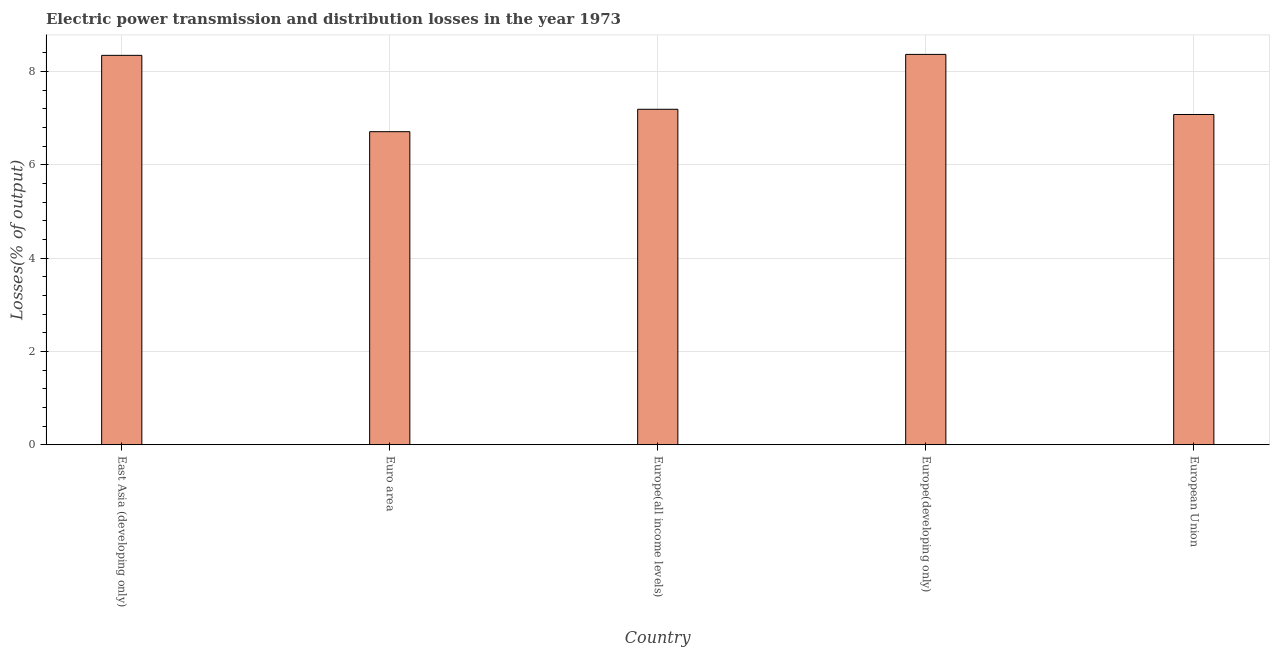What is the title of the graph?
Your response must be concise. Electric power transmission and distribution losses in the year 1973. What is the label or title of the Y-axis?
Provide a short and direct response. Losses(% of output). What is the electric power transmission and distribution losses in East Asia (developing only)?
Your answer should be very brief. 8.35. Across all countries, what is the maximum electric power transmission and distribution losses?
Provide a succinct answer. 8.37. Across all countries, what is the minimum electric power transmission and distribution losses?
Offer a terse response. 6.71. In which country was the electric power transmission and distribution losses maximum?
Offer a terse response. Europe(developing only). What is the sum of the electric power transmission and distribution losses?
Your answer should be compact. 37.7. What is the difference between the electric power transmission and distribution losses in Euro area and Europe(all income levels)?
Your response must be concise. -0.48. What is the average electric power transmission and distribution losses per country?
Provide a short and direct response. 7.54. What is the median electric power transmission and distribution losses?
Give a very brief answer. 7.19. In how many countries, is the electric power transmission and distribution losses greater than 7.2 %?
Give a very brief answer. 2. What is the difference between the highest and the second highest electric power transmission and distribution losses?
Keep it short and to the point. 0.02. What is the difference between the highest and the lowest electric power transmission and distribution losses?
Ensure brevity in your answer.  1.66. How many bars are there?
Offer a terse response. 5. Are all the bars in the graph horizontal?
Offer a very short reply. No. How many countries are there in the graph?
Provide a succinct answer. 5. What is the Losses(% of output) in East Asia (developing only)?
Ensure brevity in your answer.  8.35. What is the Losses(% of output) in Euro area?
Offer a very short reply. 6.71. What is the Losses(% of output) in Europe(all income levels)?
Provide a short and direct response. 7.19. What is the Losses(% of output) of Europe(developing only)?
Provide a short and direct response. 8.37. What is the Losses(% of output) in European Union?
Your answer should be compact. 7.08. What is the difference between the Losses(% of output) in East Asia (developing only) and Euro area?
Offer a very short reply. 1.64. What is the difference between the Losses(% of output) in East Asia (developing only) and Europe(all income levels)?
Your response must be concise. 1.16. What is the difference between the Losses(% of output) in East Asia (developing only) and Europe(developing only)?
Make the answer very short. -0.02. What is the difference between the Losses(% of output) in East Asia (developing only) and European Union?
Ensure brevity in your answer.  1.27. What is the difference between the Losses(% of output) in Euro area and Europe(all income levels)?
Offer a very short reply. -0.48. What is the difference between the Losses(% of output) in Euro area and Europe(developing only)?
Ensure brevity in your answer.  -1.66. What is the difference between the Losses(% of output) in Euro area and European Union?
Provide a short and direct response. -0.37. What is the difference between the Losses(% of output) in Europe(all income levels) and Europe(developing only)?
Give a very brief answer. -1.18. What is the difference between the Losses(% of output) in Europe(all income levels) and European Union?
Your response must be concise. 0.11. What is the difference between the Losses(% of output) in Europe(developing only) and European Union?
Offer a very short reply. 1.29. What is the ratio of the Losses(% of output) in East Asia (developing only) to that in Euro area?
Make the answer very short. 1.24. What is the ratio of the Losses(% of output) in East Asia (developing only) to that in Europe(all income levels)?
Ensure brevity in your answer.  1.16. What is the ratio of the Losses(% of output) in East Asia (developing only) to that in European Union?
Ensure brevity in your answer.  1.18. What is the ratio of the Losses(% of output) in Euro area to that in Europe(all income levels)?
Provide a short and direct response. 0.93. What is the ratio of the Losses(% of output) in Euro area to that in Europe(developing only)?
Your response must be concise. 0.8. What is the ratio of the Losses(% of output) in Euro area to that in European Union?
Ensure brevity in your answer.  0.95. What is the ratio of the Losses(% of output) in Europe(all income levels) to that in Europe(developing only)?
Your answer should be compact. 0.86. What is the ratio of the Losses(% of output) in Europe(all income levels) to that in European Union?
Provide a succinct answer. 1.02. What is the ratio of the Losses(% of output) in Europe(developing only) to that in European Union?
Ensure brevity in your answer.  1.18. 